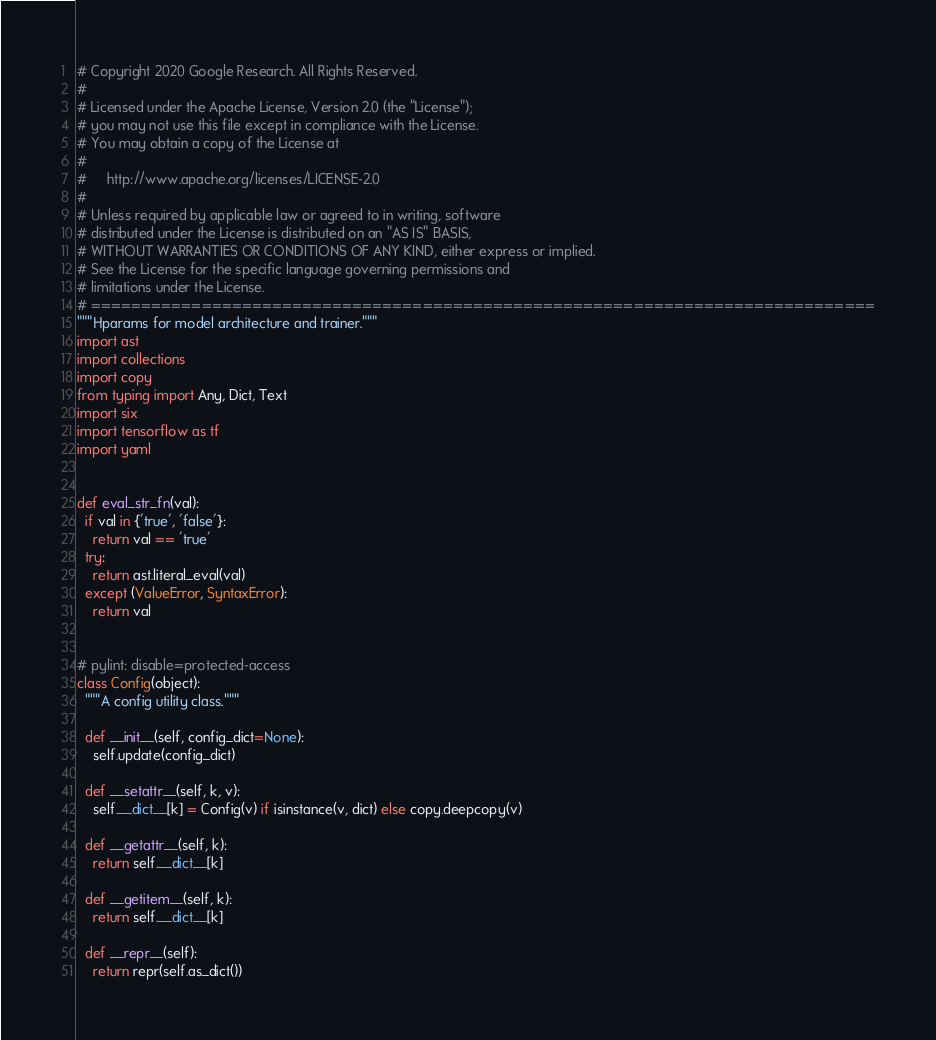<code> <loc_0><loc_0><loc_500><loc_500><_Python_># Copyright 2020 Google Research. All Rights Reserved.
#
# Licensed under the Apache License, Version 2.0 (the "License");
# you may not use this file except in compliance with the License.
# You may obtain a copy of the License at
#
#     http://www.apache.org/licenses/LICENSE-2.0
#
# Unless required by applicable law or agreed to in writing, software
# distributed under the License is distributed on an "AS IS" BASIS,
# WITHOUT WARRANTIES OR CONDITIONS OF ANY KIND, either express or implied.
# See the License for the specific language governing permissions and
# limitations under the License.
# ==============================================================================
"""Hparams for model architecture and trainer."""
import ast
import collections
import copy
from typing import Any, Dict, Text
import six
import tensorflow as tf
import yaml


def eval_str_fn(val):
  if val in {'true', 'false'}:
    return val == 'true'
  try:
    return ast.literal_eval(val)
  except (ValueError, SyntaxError):
    return val


# pylint: disable=protected-access
class Config(object):
  """A config utility class."""

  def __init__(self, config_dict=None):
    self.update(config_dict)

  def __setattr__(self, k, v):
    self.__dict__[k] = Config(v) if isinstance(v, dict) else copy.deepcopy(v)

  def __getattr__(self, k):
    return self.__dict__[k]

  def __getitem__(self, k):
    return self.__dict__[k]

  def __repr__(self):
    return repr(self.as_dict())
</code> 